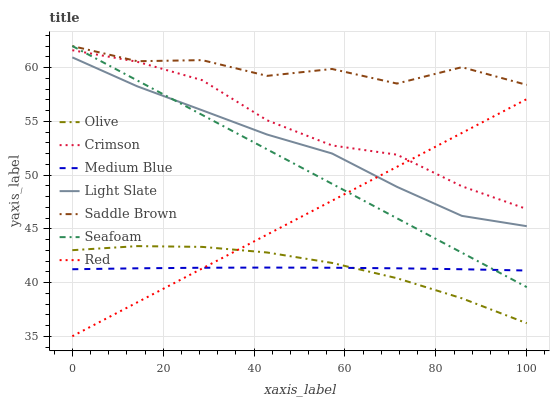Does Medium Blue have the minimum area under the curve?
Answer yes or no. Yes. Does Saddle Brown have the maximum area under the curve?
Answer yes or no. Yes. Does Seafoam have the minimum area under the curve?
Answer yes or no. No. Does Seafoam have the maximum area under the curve?
Answer yes or no. No. Is Red the smoothest?
Answer yes or no. Yes. Is Saddle Brown the roughest?
Answer yes or no. Yes. Is Medium Blue the smoothest?
Answer yes or no. No. Is Medium Blue the roughest?
Answer yes or no. No. Does Red have the lowest value?
Answer yes or no. Yes. Does Medium Blue have the lowest value?
Answer yes or no. No. Does Seafoam have the highest value?
Answer yes or no. Yes. Does Medium Blue have the highest value?
Answer yes or no. No. Is Olive less than Seafoam?
Answer yes or no. Yes. Is Crimson greater than Light Slate?
Answer yes or no. Yes. Does Medium Blue intersect Olive?
Answer yes or no. Yes. Is Medium Blue less than Olive?
Answer yes or no. No. Is Medium Blue greater than Olive?
Answer yes or no. No. Does Olive intersect Seafoam?
Answer yes or no. No. 